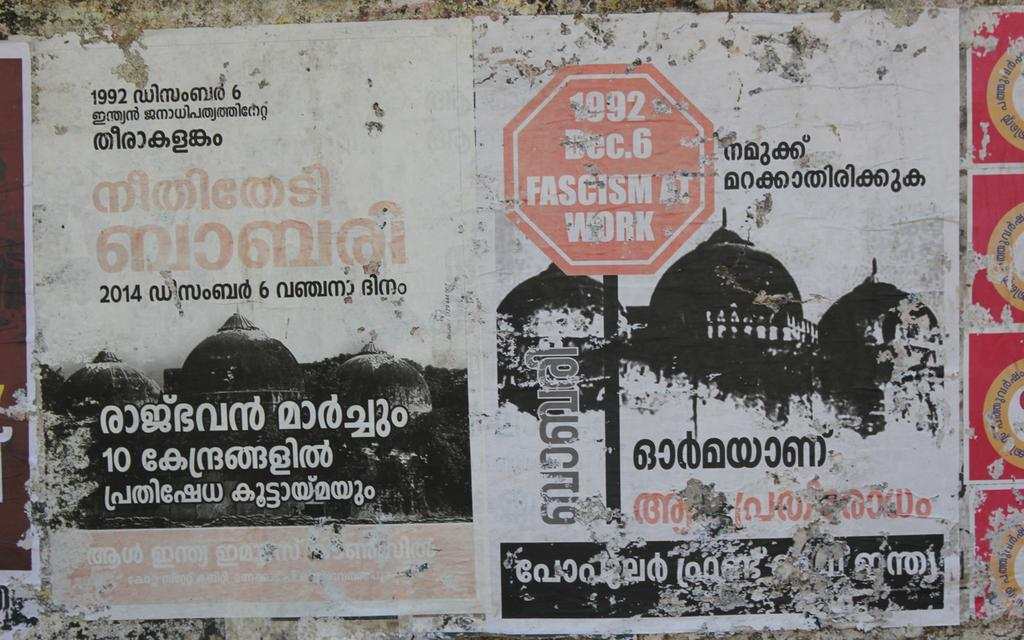<image>
Write a terse but informative summary of the picture. A ragged poster with a stop sign that reads 1922 Dec. 6 sits against a wall 